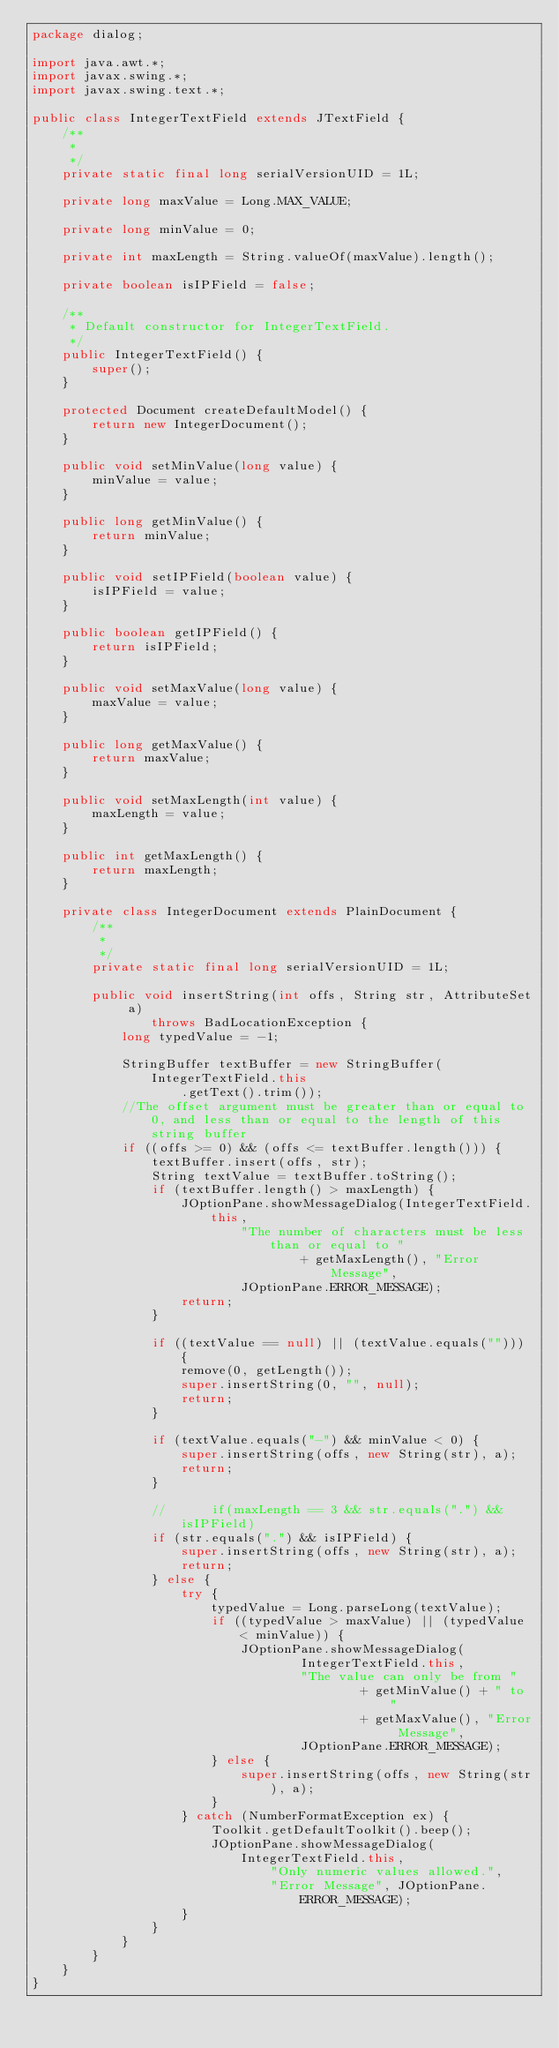Convert code to text. <code><loc_0><loc_0><loc_500><loc_500><_Java_>package dialog;

import java.awt.*;
import javax.swing.*;
import javax.swing.text.*;

public class IntegerTextField extends JTextField {
	/**
	 * 
	 */
	private static final long serialVersionUID = 1L;

	private long maxValue = Long.MAX_VALUE;

	private long minValue = 0;

	private int maxLength = String.valueOf(maxValue).length();

	private boolean isIPField = false;

	/**
	 * Default constructor for IntegerTextField.
	 */
	public IntegerTextField() {
		super();
	}

	protected Document createDefaultModel() {
		return new IntegerDocument();
	}

	public void setMinValue(long value) {
		minValue = value;
	}

	public long getMinValue() {
		return minValue;
	}

	public void setIPField(boolean value) {
		isIPField = value;
	}

	public boolean getIPField() {
		return isIPField;
	}

	public void setMaxValue(long value) {
		maxValue = value;
	}

	public long getMaxValue() {
		return maxValue;
	}

	public void setMaxLength(int value) {
		maxLength = value;
	}

	public int getMaxLength() {
		return maxLength;
	}

	private class IntegerDocument extends PlainDocument {
		/**
		 * 
		 */
		private static final long serialVersionUID = 1L;

		public void insertString(int offs, String str, AttributeSet a)
				throws BadLocationException {
			long typedValue = -1;

			StringBuffer textBuffer = new StringBuffer(IntegerTextField.this
					.getText().trim());
			//The offset argument must be greater than or equal to 0, and less than or equal to the length of this string buffer
			if ((offs >= 0) && (offs <= textBuffer.length())) {
				textBuffer.insert(offs, str);
				String textValue = textBuffer.toString();
				if (textBuffer.length() > maxLength) {
					JOptionPane.showMessageDialog(IntegerTextField.this,
							"The number of characters must be less than or equal to "
									+ getMaxLength(), "Error Message",
							JOptionPane.ERROR_MESSAGE);
					return;
				}

				if ((textValue == null) || (textValue.equals(""))) {
					remove(0, getLength());
					super.insertString(0, "", null);
					return;
				}

				if (textValue.equals("-") && minValue < 0) {
					super.insertString(offs, new String(str), a);
					return;
				}

				// 	    if(maxLength == 3 && str.equals(".") && isIPField)
				if (str.equals(".") && isIPField) {
					super.insertString(offs, new String(str), a);
					return;
				} else {
					try {
						typedValue = Long.parseLong(textValue);
						if ((typedValue > maxValue) || (typedValue < minValue)) {
							JOptionPane.showMessageDialog(
									IntegerTextField.this,
									"The value can only be from "
											+ getMinValue() + " to "
											+ getMaxValue(), "Error Message",
									JOptionPane.ERROR_MESSAGE);
						} else {
							super.insertString(offs, new String(str), a);
						}
					} catch (NumberFormatException ex) {
						Toolkit.getDefaultToolkit().beep();
						JOptionPane.showMessageDialog(IntegerTextField.this,
								"Only numeric values allowed.",
								"Error Message", JOptionPane.ERROR_MESSAGE);
					}
				}
			}
		}
	}
}</code> 